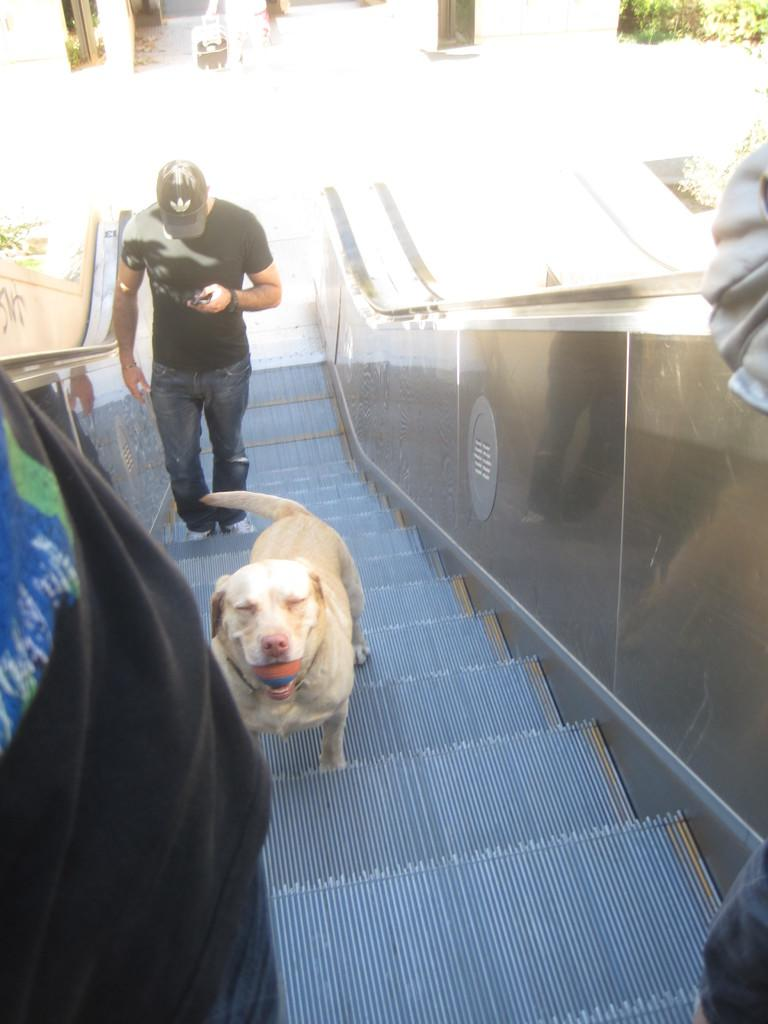What type of animal can be seen in the image? There is a dog in the image. What is the person in the image doing? The person is holding a mobile phone in the image. Where is the person located in the image? The person is standing on an escalator in the image. What can be seen in the background of the image? There is a building and plants in the background of the image. Where is the shelf located in the image? There is no shelf present in the image. What type of boat can be seen in the image? There is no boat present in the image. 